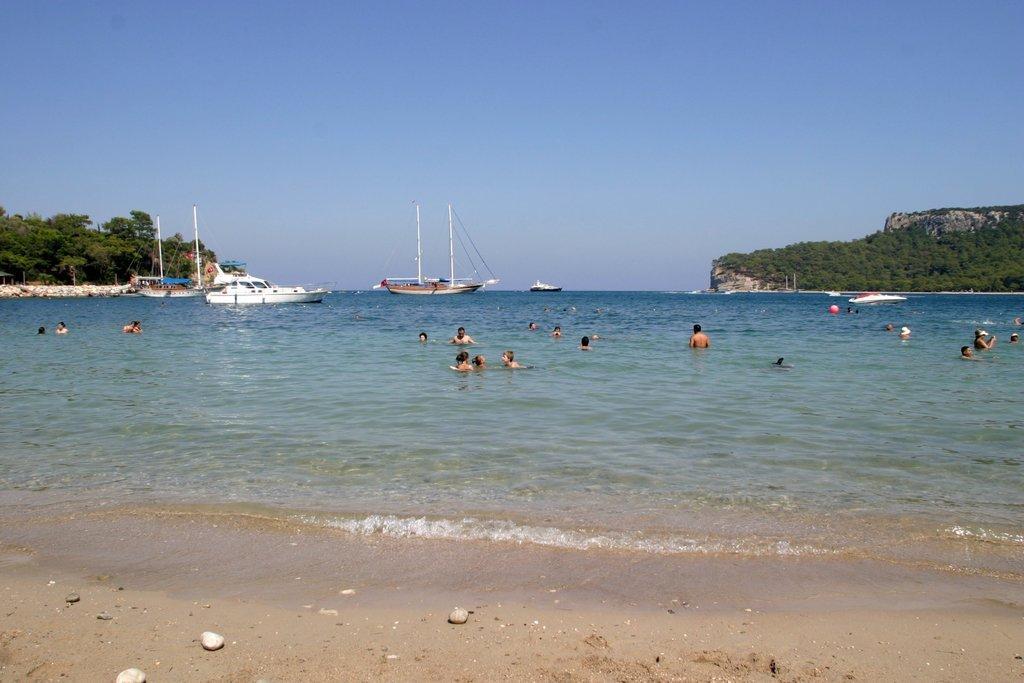Describe this image in one or two sentences. In the picture we can see a part of the sand surface and water surface, in the water we can see some people and far away from them, we can see some boats with poles on it and on the both the sides of the water we can see the trees and in the background we can see the sky. 